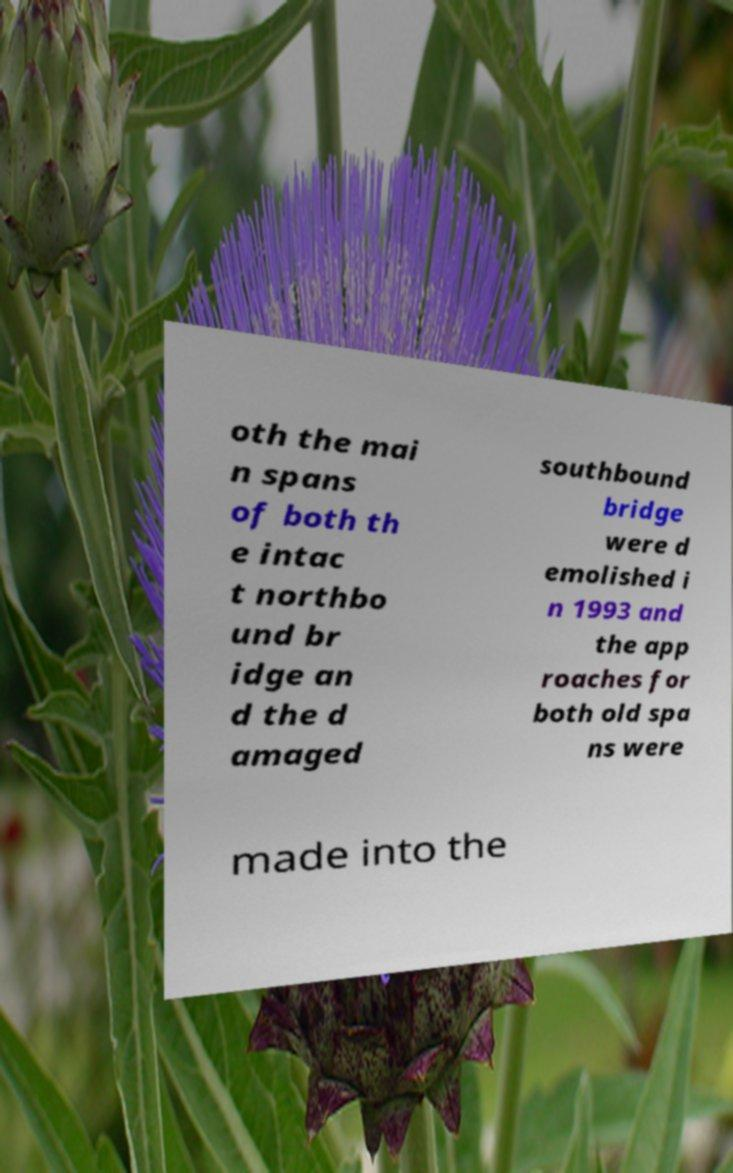Could you assist in decoding the text presented in this image and type it out clearly? oth the mai n spans of both th e intac t northbo und br idge an d the d amaged southbound bridge were d emolished i n 1993 and the app roaches for both old spa ns were made into the 